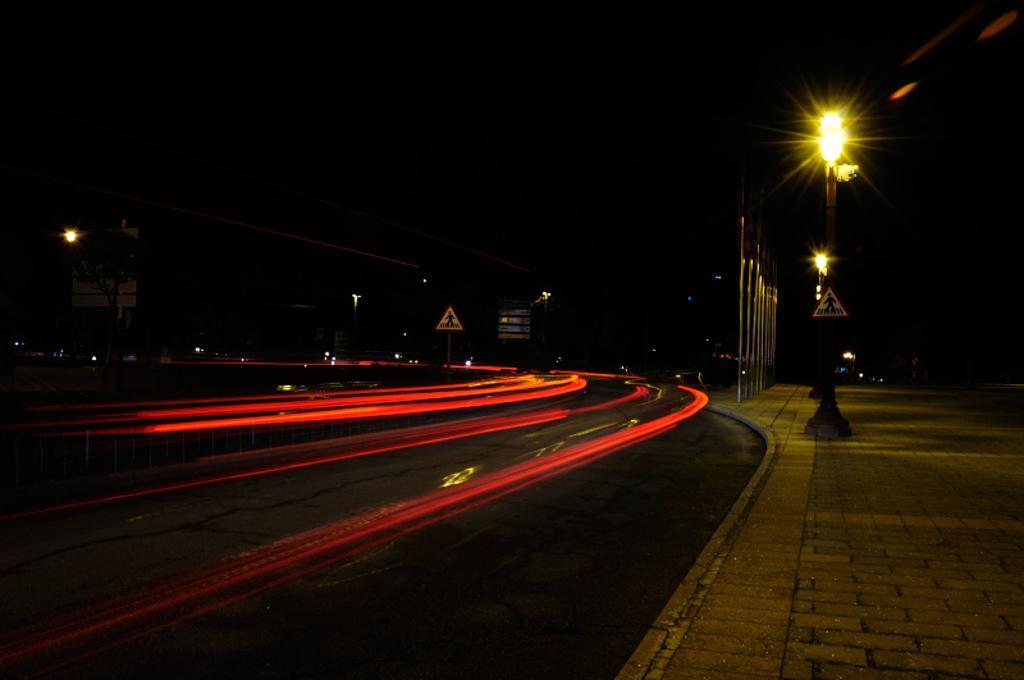How would you summarize this image in a sentence or two? In this picture we can see few poles, lights and sign boards, and also we can see dark background. 